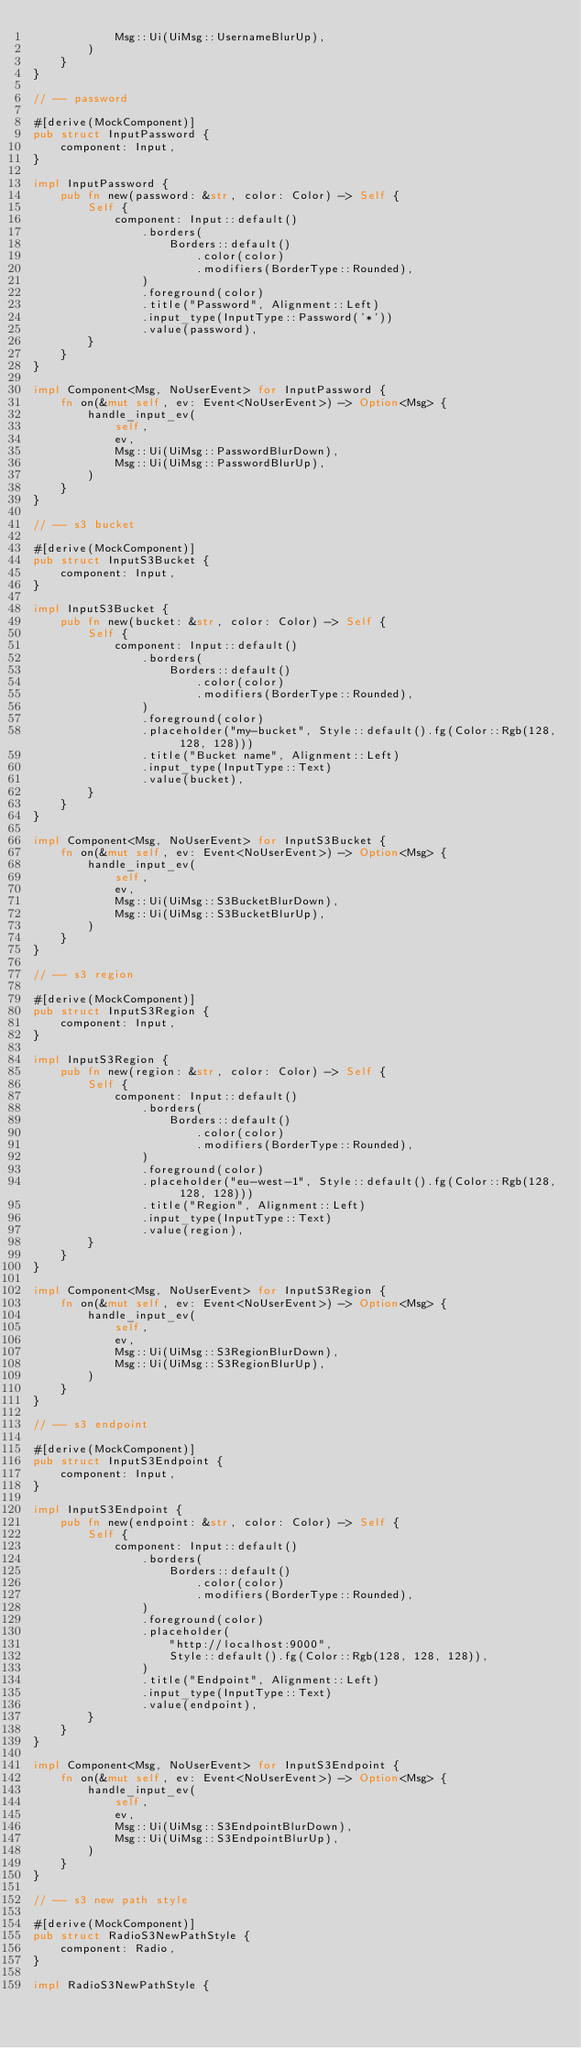Convert code to text. <code><loc_0><loc_0><loc_500><loc_500><_Rust_>            Msg::Ui(UiMsg::UsernameBlurUp),
        )
    }
}

// -- password

#[derive(MockComponent)]
pub struct InputPassword {
    component: Input,
}

impl InputPassword {
    pub fn new(password: &str, color: Color) -> Self {
        Self {
            component: Input::default()
                .borders(
                    Borders::default()
                        .color(color)
                        .modifiers(BorderType::Rounded),
                )
                .foreground(color)
                .title("Password", Alignment::Left)
                .input_type(InputType::Password('*'))
                .value(password),
        }
    }
}

impl Component<Msg, NoUserEvent> for InputPassword {
    fn on(&mut self, ev: Event<NoUserEvent>) -> Option<Msg> {
        handle_input_ev(
            self,
            ev,
            Msg::Ui(UiMsg::PasswordBlurDown),
            Msg::Ui(UiMsg::PasswordBlurUp),
        )
    }
}

// -- s3 bucket

#[derive(MockComponent)]
pub struct InputS3Bucket {
    component: Input,
}

impl InputS3Bucket {
    pub fn new(bucket: &str, color: Color) -> Self {
        Self {
            component: Input::default()
                .borders(
                    Borders::default()
                        .color(color)
                        .modifiers(BorderType::Rounded),
                )
                .foreground(color)
                .placeholder("my-bucket", Style::default().fg(Color::Rgb(128, 128, 128)))
                .title("Bucket name", Alignment::Left)
                .input_type(InputType::Text)
                .value(bucket),
        }
    }
}

impl Component<Msg, NoUserEvent> for InputS3Bucket {
    fn on(&mut self, ev: Event<NoUserEvent>) -> Option<Msg> {
        handle_input_ev(
            self,
            ev,
            Msg::Ui(UiMsg::S3BucketBlurDown),
            Msg::Ui(UiMsg::S3BucketBlurUp),
        )
    }
}

// -- s3 region

#[derive(MockComponent)]
pub struct InputS3Region {
    component: Input,
}

impl InputS3Region {
    pub fn new(region: &str, color: Color) -> Self {
        Self {
            component: Input::default()
                .borders(
                    Borders::default()
                        .color(color)
                        .modifiers(BorderType::Rounded),
                )
                .foreground(color)
                .placeholder("eu-west-1", Style::default().fg(Color::Rgb(128, 128, 128)))
                .title("Region", Alignment::Left)
                .input_type(InputType::Text)
                .value(region),
        }
    }
}

impl Component<Msg, NoUserEvent> for InputS3Region {
    fn on(&mut self, ev: Event<NoUserEvent>) -> Option<Msg> {
        handle_input_ev(
            self,
            ev,
            Msg::Ui(UiMsg::S3RegionBlurDown),
            Msg::Ui(UiMsg::S3RegionBlurUp),
        )
    }
}

// -- s3 endpoint

#[derive(MockComponent)]
pub struct InputS3Endpoint {
    component: Input,
}

impl InputS3Endpoint {
    pub fn new(endpoint: &str, color: Color) -> Self {
        Self {
            component: Input::default()
                .borders(
                    Borders::default()
                        .color(color)
                        .modifiers(BorderType::Rounded),
                )
                .foreground(color)
                .placeholder(
                    "http://localhost:9000",
                    Style::default().fg(Color::Rgb(128, 128, 128)),
                )
                .title("Endpoint", Alignment::Left)
                .input_type(InputType::Text)
                .value(endpoint),
        }
    }
}

impl Component<Msg, NoUserEvent> for InputS3Endpoint {
    fn on(&mut self, ev: Event<NoUserEvent>) -> Option<Msg> {
        handle_input_ev(
            self,
            ev,
            Msg::Ui(UiMsg::S3EndpointBlurDown),
            Msg::Ui(UiMsg::S3EndpointBlurUp),
        )
    }
}

// -- s3 new path style

#[derive(MockComponent)]
pub struct RadioS3NewPathStyle {
    component: Radio,
}

impl RadioS3NewPathStyle {</code> 